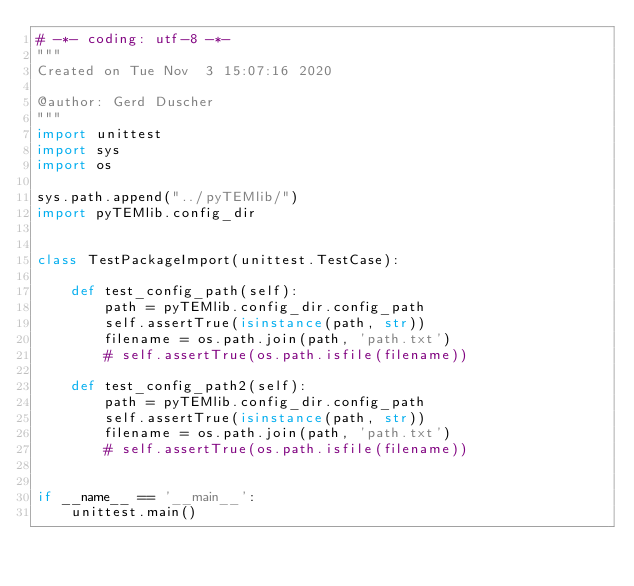Convert code to text. <code><loc_0><loc_0><loc_500><loc_500><_Python_># -*- coding: utf-8 -*-
"""
Created on Tue Nov  3 15:07:16 2020

@author: Gerd Duscher
"""
import unittest
import sys
import os

sys.path.append("../pyTEMlib/")
import pyTEMlib.config_dir


class TestPackageImport(unittest.TestCase):

    def test_config_path(self):
        path = pyTEMlib.config_dir.config_path
        self.assertTrue(isinstance(path, str))
        filename = os.path.join(path, 'path.txt')
        # self.assertTrue(os.path.isfile(filename))

    def test_config_path2(self):
        path = pyTEMlib.config_dir.config_path
        self.assertTrue(isinstance(path, str))
        filename = os.path.join(path, 'path.txt')
        # self.assertTrue(os.path.isfile(filename))


if __name__ == '__main__':
    unittest.main()
</code> 